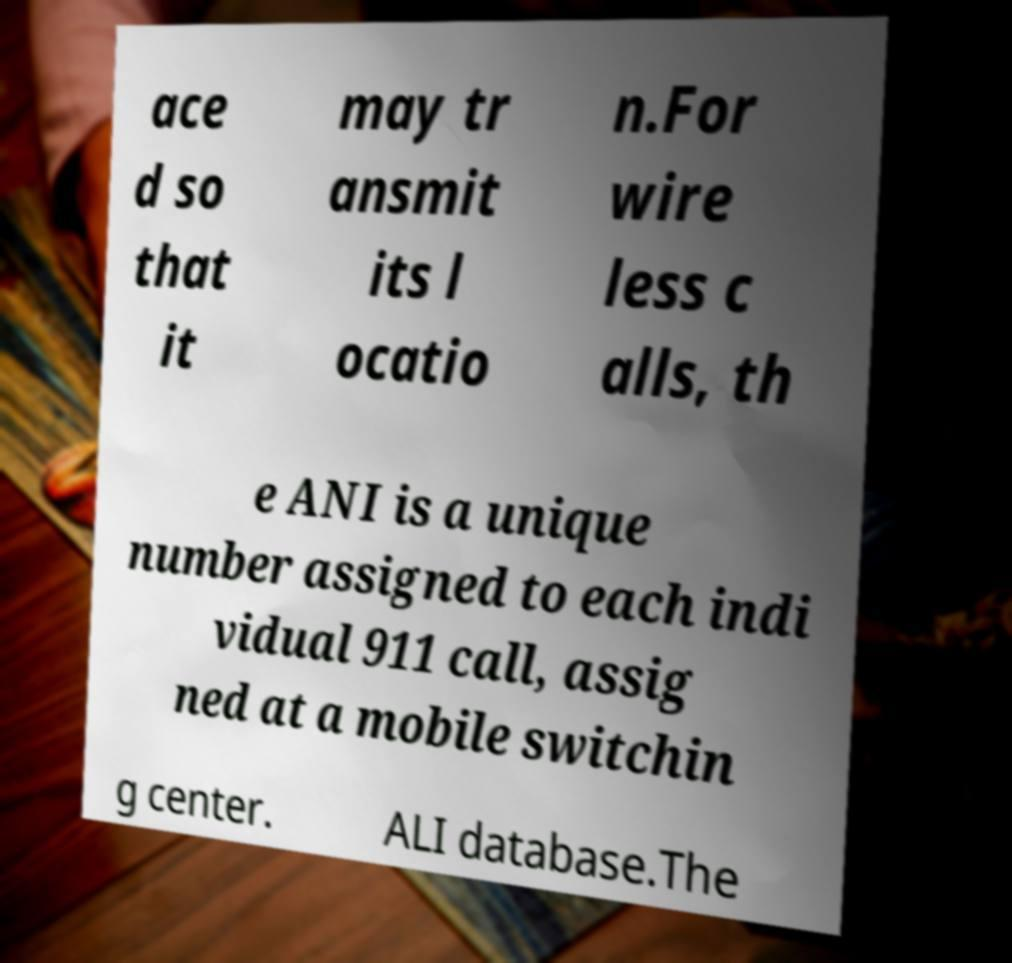Please identify and transcribe the text found in this image. ace d so that it may tr ansmit its l ocatio n.For wire less c alls, th e ANI is a unique number assigned to each indi vidual 911 call, assig ned at a mobile switchin g center. ALI database.The 